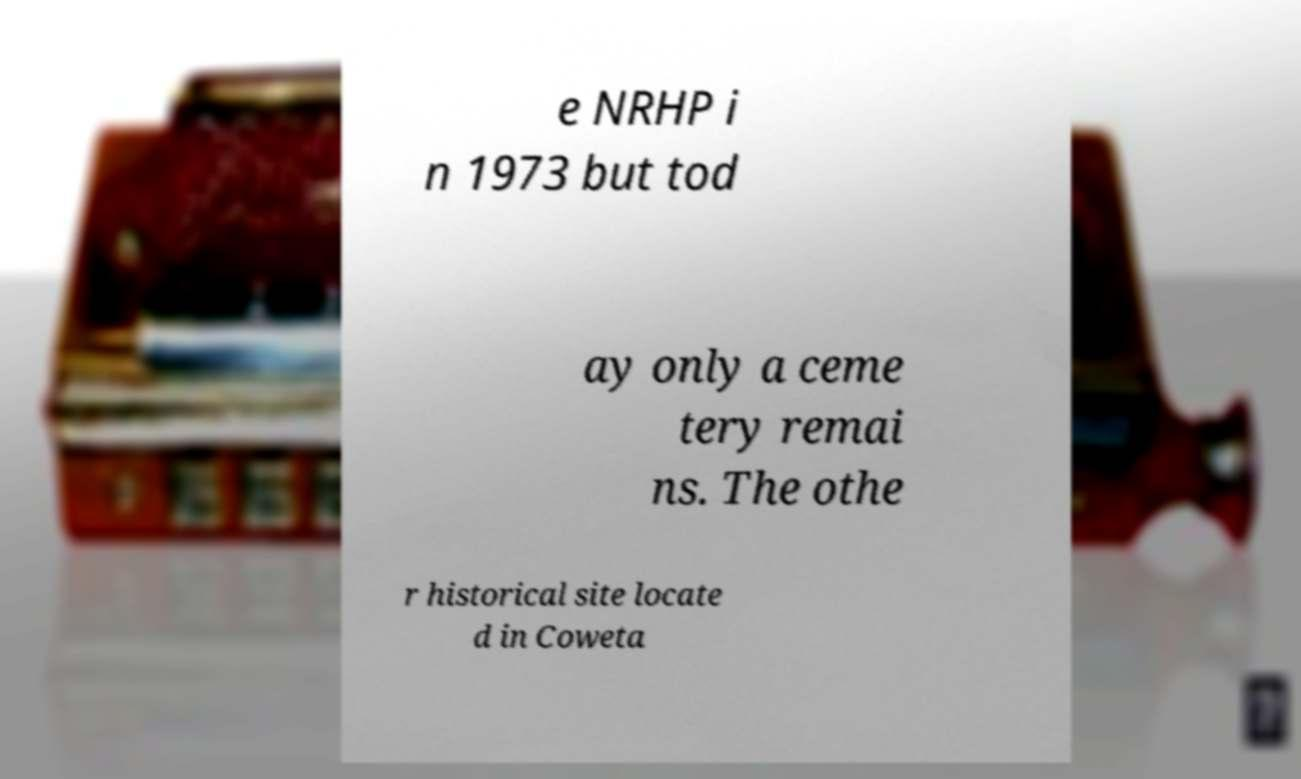Can you accurately transcribe the text from the provided image for me? e NRHP i n 1973 but tod ay only a ceme tery remai ns. The othe r historical site locate d in Coweta 